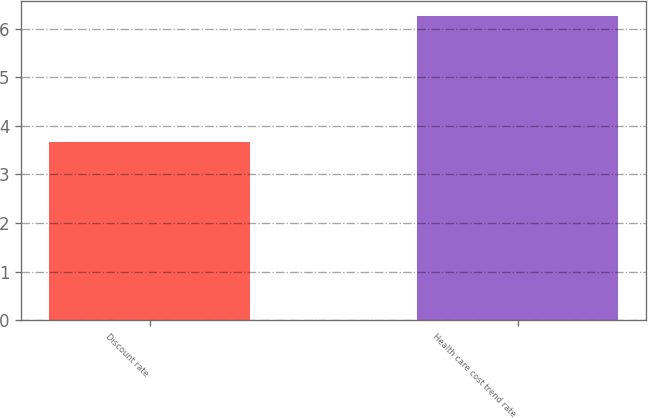<chart> <loc_0><loc_0><loc_500><loc_500><bar_chart><fcel>Discount rate<fcel>Health care cost trend rate<nl><fcel>3.66<fcel>6.25<nl></chart> 